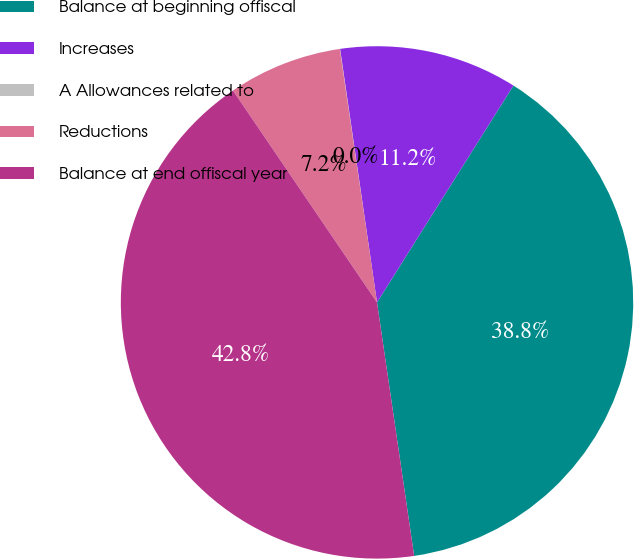<chart> <loc_0><loc_0><loc_500><loc_500><pie_chart><fcel>Balance at beginning offiscal<fcel>Increases<fcel>A Allowances related to<fcel>Reductions<fcel>Balance at end offiscal year<nl><fcel>38.75%<fcel>11.24%<fcel>0.02%<fcel>7.18%<fcel>42.81%<nl></chart> 